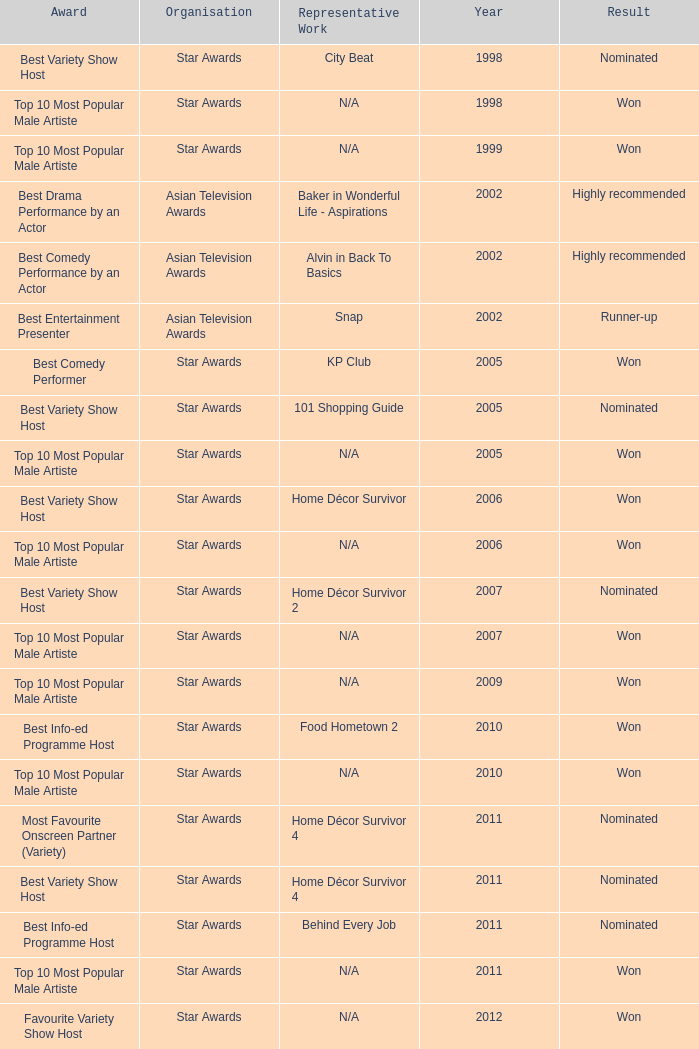What is the award for the Star Awards earlier than 2005 and the result is won? Top 10 Most Popular Male Artiste, Top 10 Most Popular Male Artiste. 